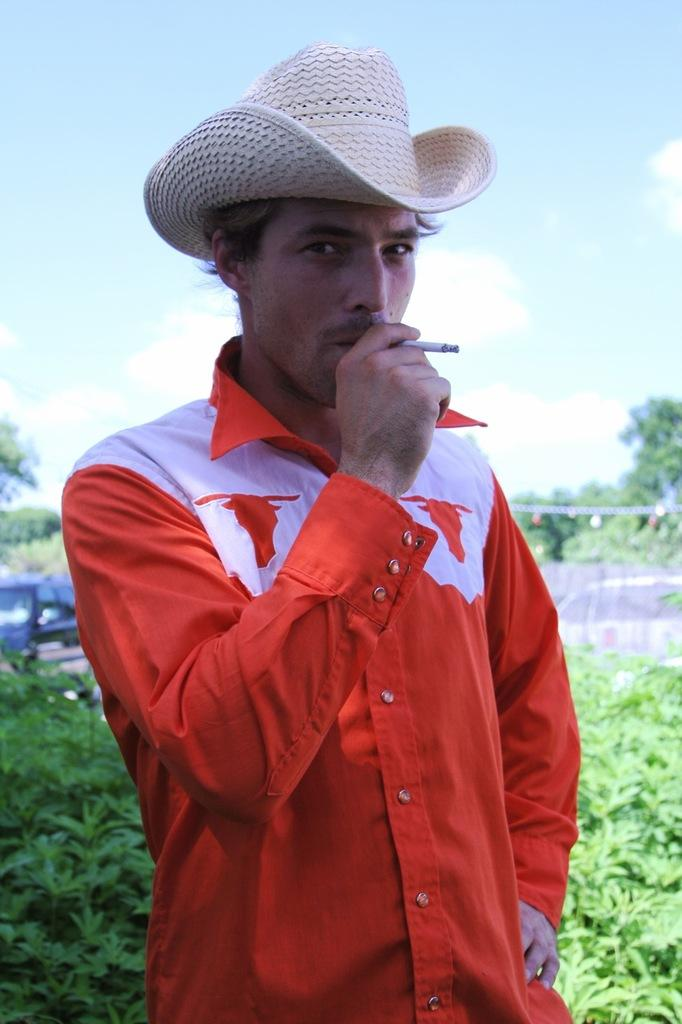What is the man in the image doing? The man is standing in the image. What is the man wearing on his upper body? The man is wearing a shirt. What is the man wearing on his head? The man is wearing a hat. What is the man holding in his hand? The man is holding a cigarette in his hand. What can be seen in the background of the image? There is greenery, a car, and the sky visible in the background of the image. What is the condition of the sky in the image? Clouds are present in the sky. How many dimes can be seen on the man's hat in the image? There are no dimes visible on the man's hat in the image. What type of badge is the man wearing on his shirt in the image? The man is not wearing a badge on his shirt in the image. 